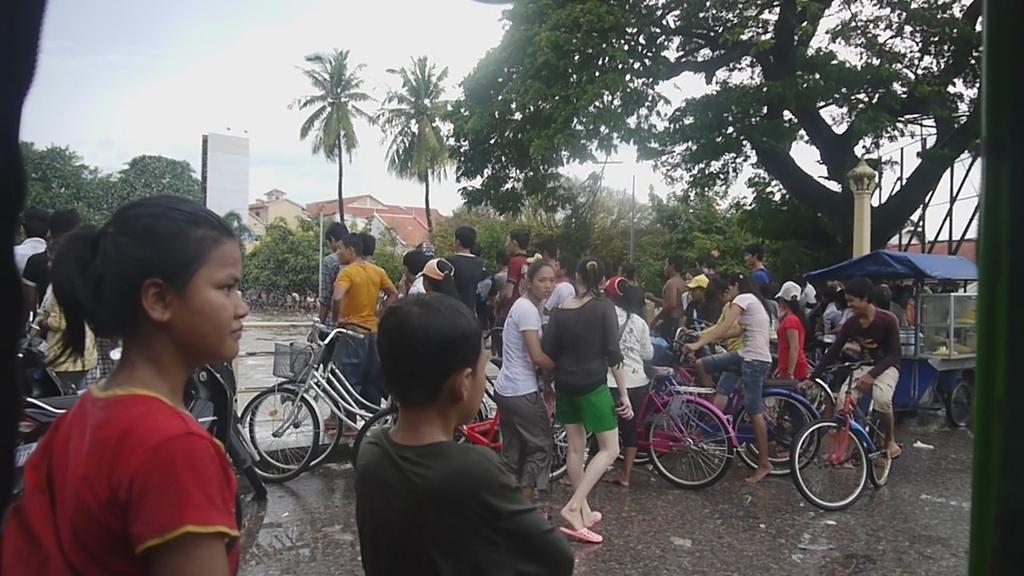Can you describe this image briefly? In this image, there are group of people standing and some are riding bicycle on the road. Next to that a tea stall is there and tree is visible on the right top. A sky is visible on the left top. In the middle of the background, there are houses visible. This image is taken during day time. 